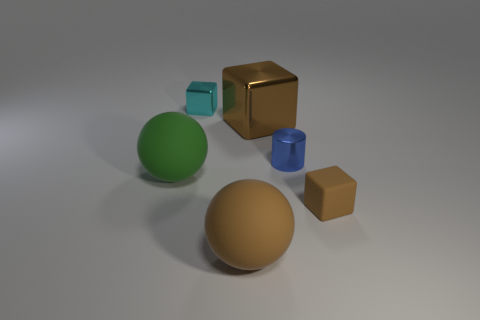Subtract all yellow cylinders. Subtract all blue spheres. How many cylinders are left? 1 Add 4 small rubber things. How many objects exist? 10 Subtract all cylinders. How many objects are left? 5 Add 6 tiny cyan things. How many tiny cyan things exist? 7 Subtract 0 purple cylinders. How many objects are left? 6 Subtract all tiny blue metallic things. Subtract all tiny cylinders. How many objects are left? 4 Add 5 big brown matte spheres. How many big brown matte spheres are left? 6 